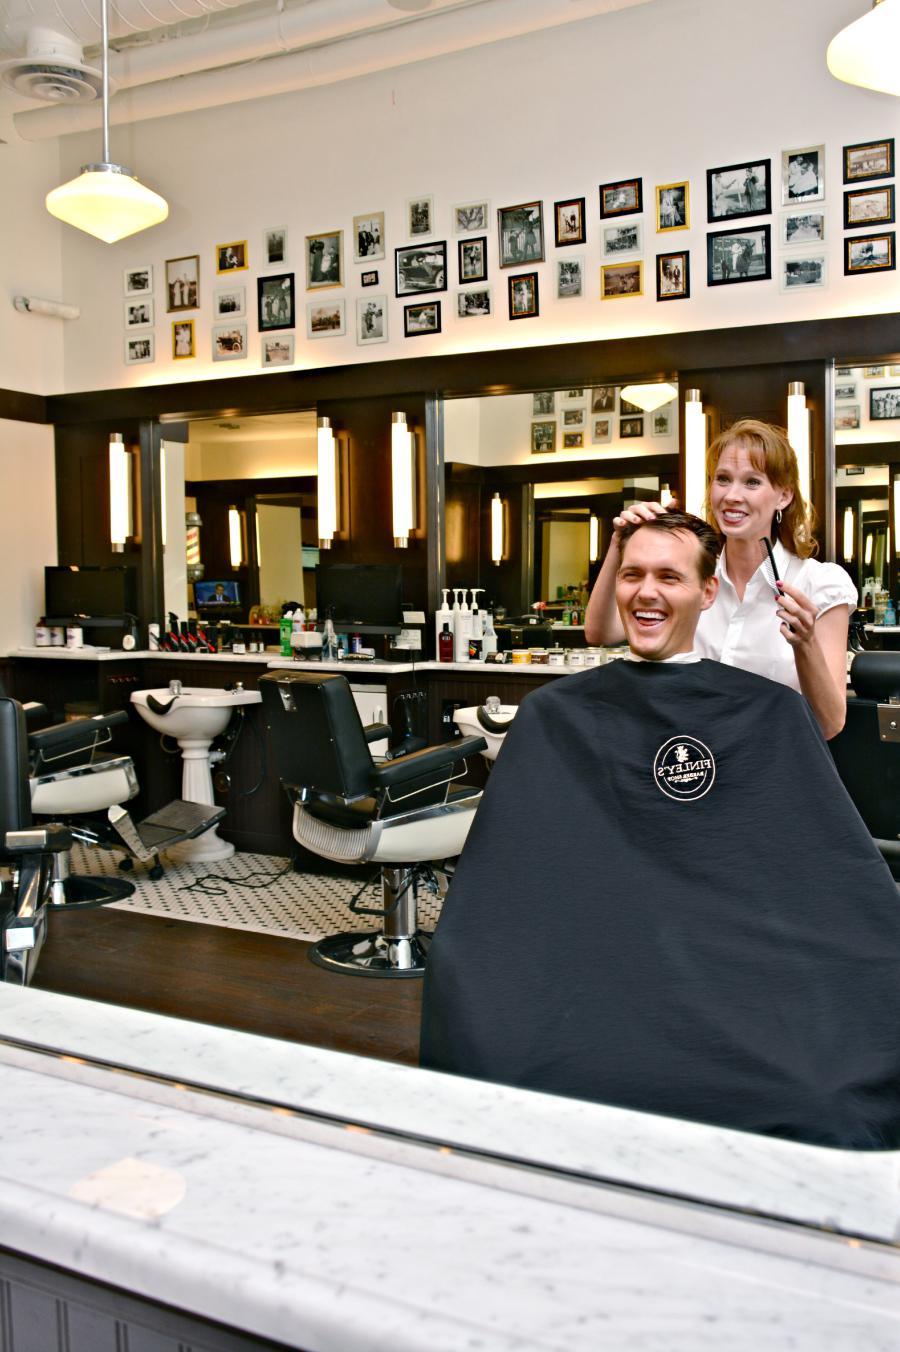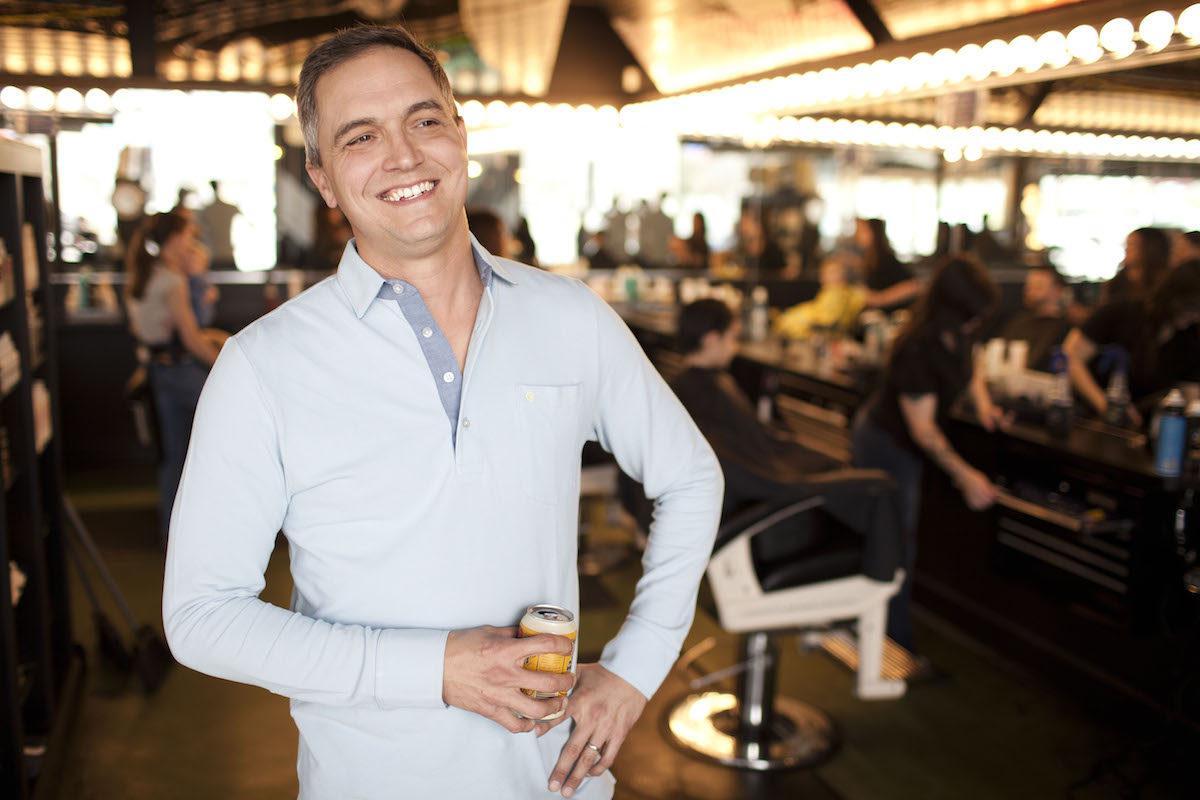The first image is the image on the left, the second image is the image on the right. For the images shown, is this caption "One person is sitting in a barbers chair." true? Answer yes or no. Yes. The first image is the image on the left, the second image is the image on the right. Analyze the images presented: Is the assertion "In one of the images a male customer is being styled by a woman stylist." valid? Answer yes or no. Yes. 